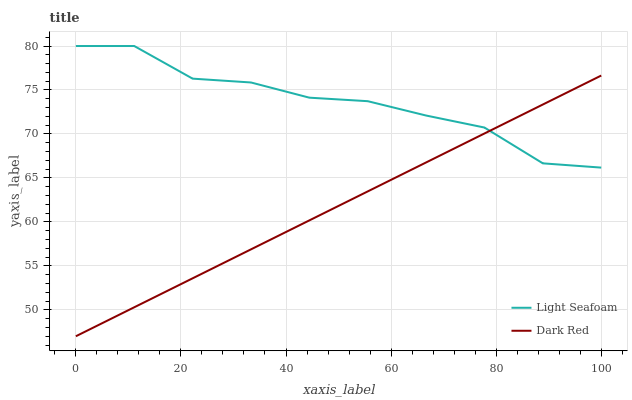Does Dark Red have the minimum area under the curve?
Answer yes or no. Yes. Does Light Seafoam have the maximum area under the curve?
Answer yes or no. Yes. Does Light Seafoam have the minimum area under the curve?
Answer yes or no. No. Is Dark Red the smoothest?
Answer yes or no. Yes. Is Light Seafoam the roughest?
Answer yes or no. Yes. Is Light Seafoam the smoothest?
Answer yes or no. No. Does Dark Red have the lowest value?
Answer yes or no. Yes. Does Light Seafoam have the lowest value?
Answer yes or no. No. Does Light Seafoam have the highest value?
Answer yes or no. Yes. Does Dark Red intersect Light Seafoam?
Answer yes or no. Yes. Is Dark Red less than Light Seafoam?
Answer yes or no. No. Is Dark Red greater than Light Seafoam?
Answer yes or no. No. 